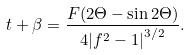Convert formula to latex. <formula><loc_0><loc_0><loc_500><loc_500>t + \beta = \frac { F ( 2 \Theta - \sin 2 \Theta ) } { 4 { | f ^ { 2 } - 1 | } ^ { 3 / 2 } } .</formula> 